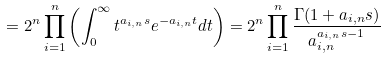<formula> <loc_0><loc_0><loc_500><loc_500>= 2 ^ { n } \prod _ { i = 1 } ^ { n } \left ( \int _ { 0 } ^ { \infty } t ^ { { a _ { i , n } } s } e ^ { - { a _ { i , n } } t } d t \right ) = 2 ^ { n } \prod _ { i = 1 } ^ { n } \frac { \Gamma ( 1 + a _ { i , n } s ) } { a _ { i , n } ^ { a _ { i , n } s - 1 } }</formula> 